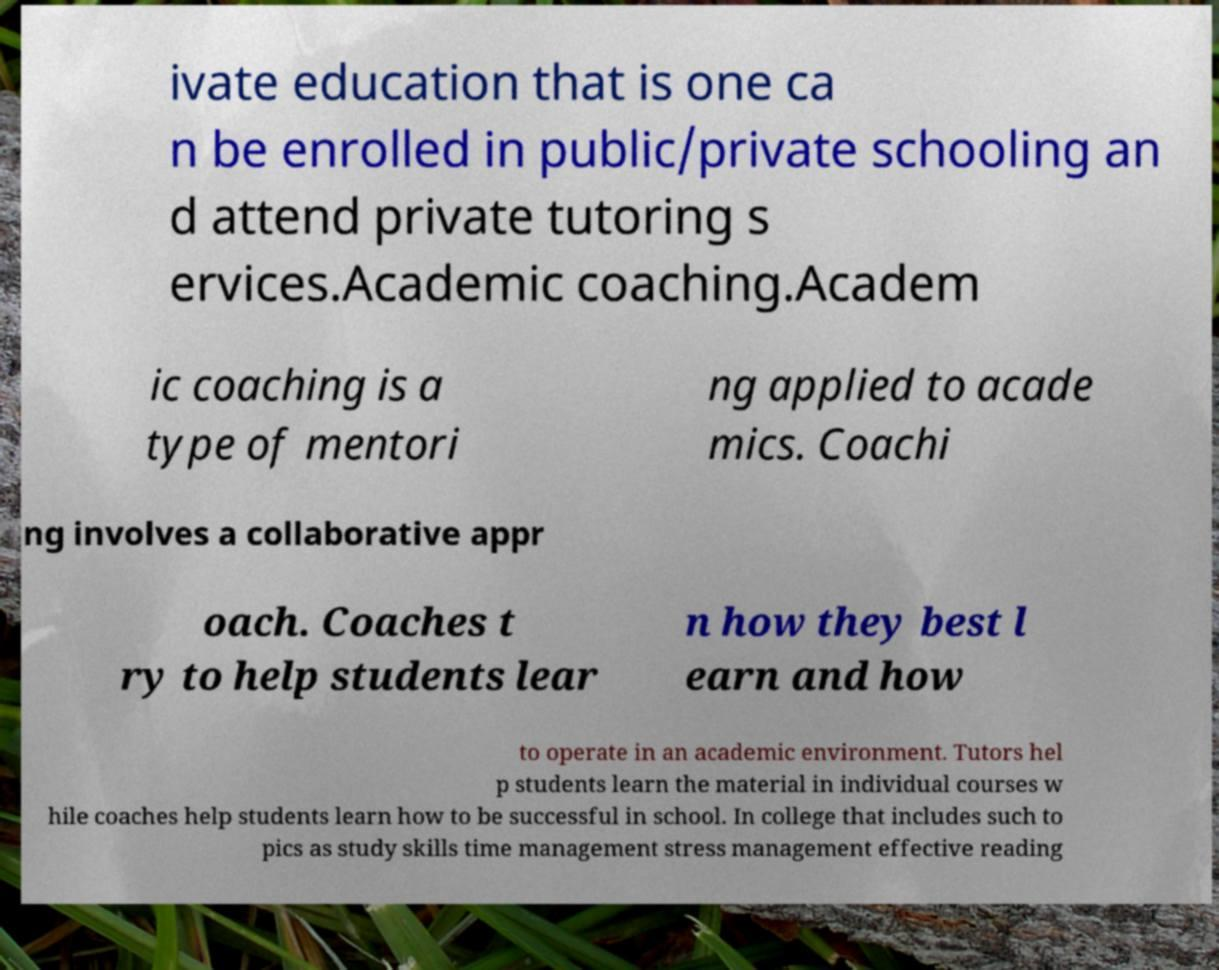What messages or text are displayed in this image? I need them in a readable, typed format. ivate education that is one ca n be enrolled in public/private schooling an d attend private tutoring s ervices.Academic coaching.Academ ic coaching is a type of mentori ng applied to acade mics. Coachi ng involves a collaborative appr oach. Coaches t ry to help students lear n how they best l earn and how to operate in an academic environment. Tutors hel p students learn the material in individual courses w hile coaches help students learn how to be successful in school. In college that includes such to pics as study skills time management stress management effective reading 